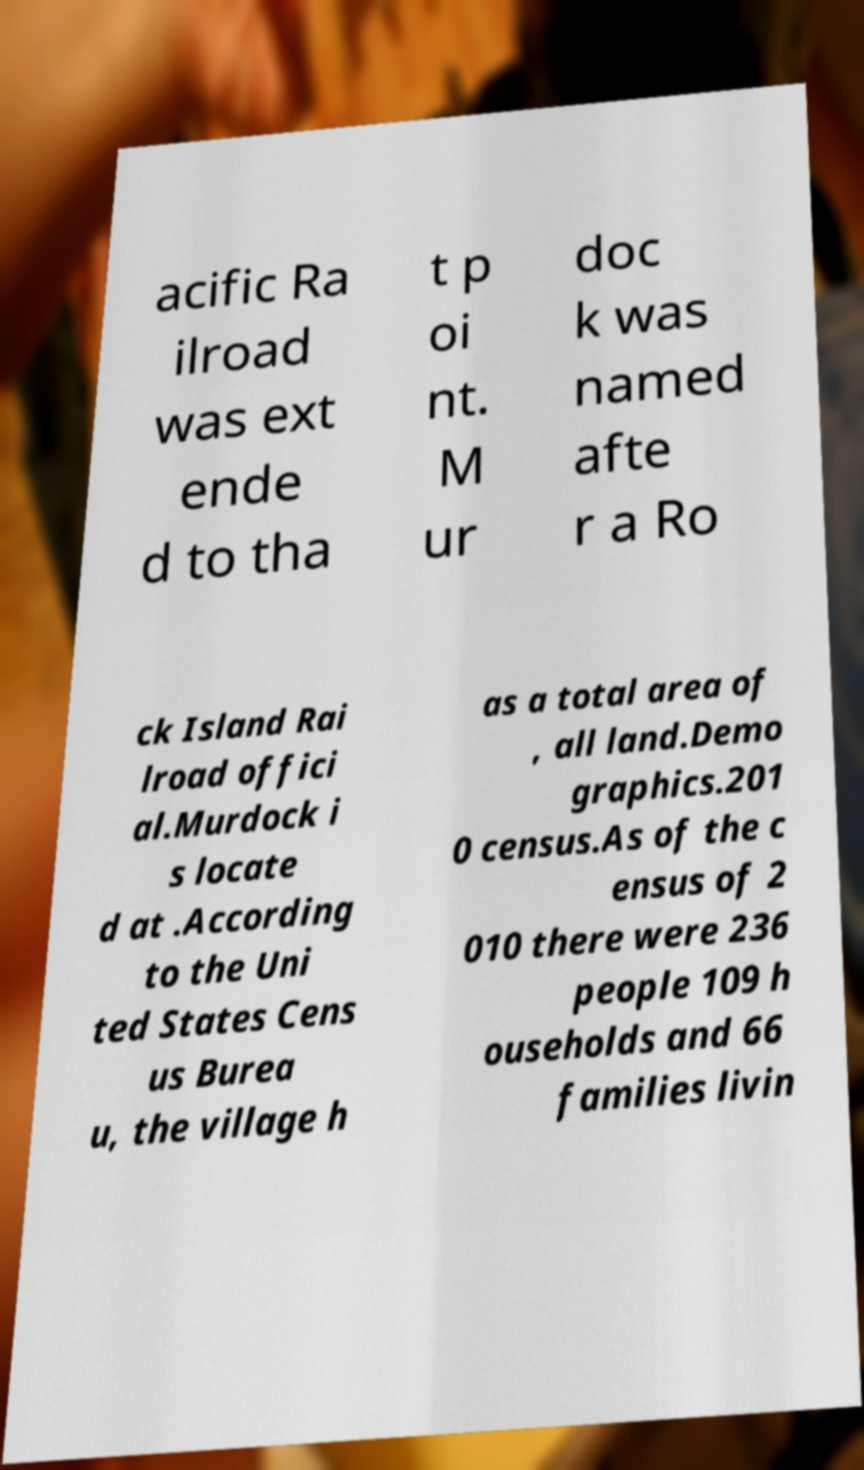What messages or text are displayed in this image? I need them in a readable, typed format. acific Ra ilroad was ext ende d to tha t p oi nt. M ur doc k was named afte r a Ro ck Island Rai lroad offici al.Murdock i s locate d at .According to the Uni ted States Cens us Burea u, the village h as a total area of , all land.Demo graphics.201 0 census.As of the c ensus of 2 010 there were 236 people 109 h ouseholds and 66 families livin 